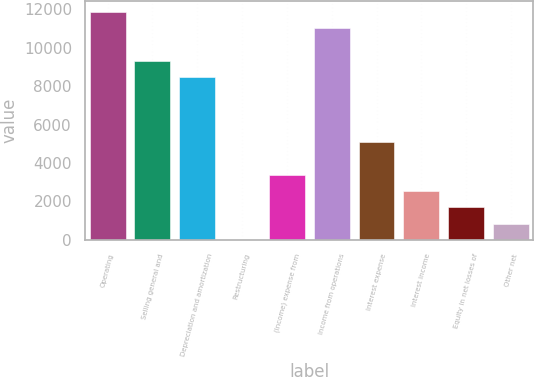<chart> <loc_0><loc_0><loc_500><loc_500><bar_chart><fcel>Operating<fcel>Selling general and<fcel>Depreciation and amortization<fcel>Restructuring<fcel>(Income) expense from<fcel>Income from operations<fcel>Interest expense<fcel>Interest income<fcel>Equity in net losses of<fcel>Other net<nl><fcel>11851.6<fcel>9312.4<fcel>8466<fcel>2<fcel>3387.6<fcel>11005.2<fcel>5080.4<fcel>2541.2<fcel>1694.8<fcel>848.4<nl></chart> 